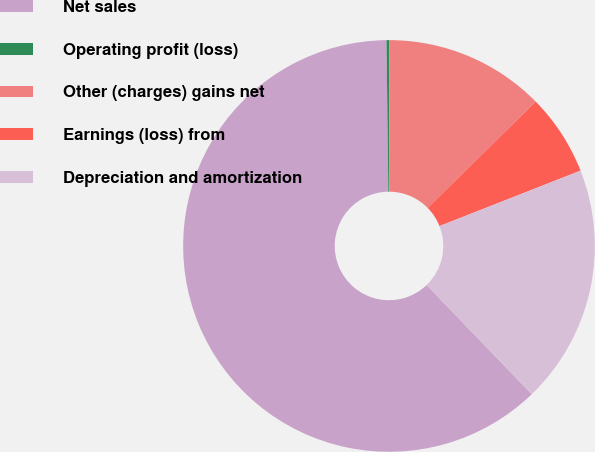<chart> <loc_0><loc_0><loc_500><loc_500><pie_chart><fcel>Net sales<fcel>Operating profit (loss)<fcel>Other (charges) gains net<fcel>Earnings (loss) from<fcel>Depreciation and amortization<nl><fcel>62.0%<fcel>0.23%<fcel>12.59%<fcel>6.41%<fcel>18.76%<nl></chart> 